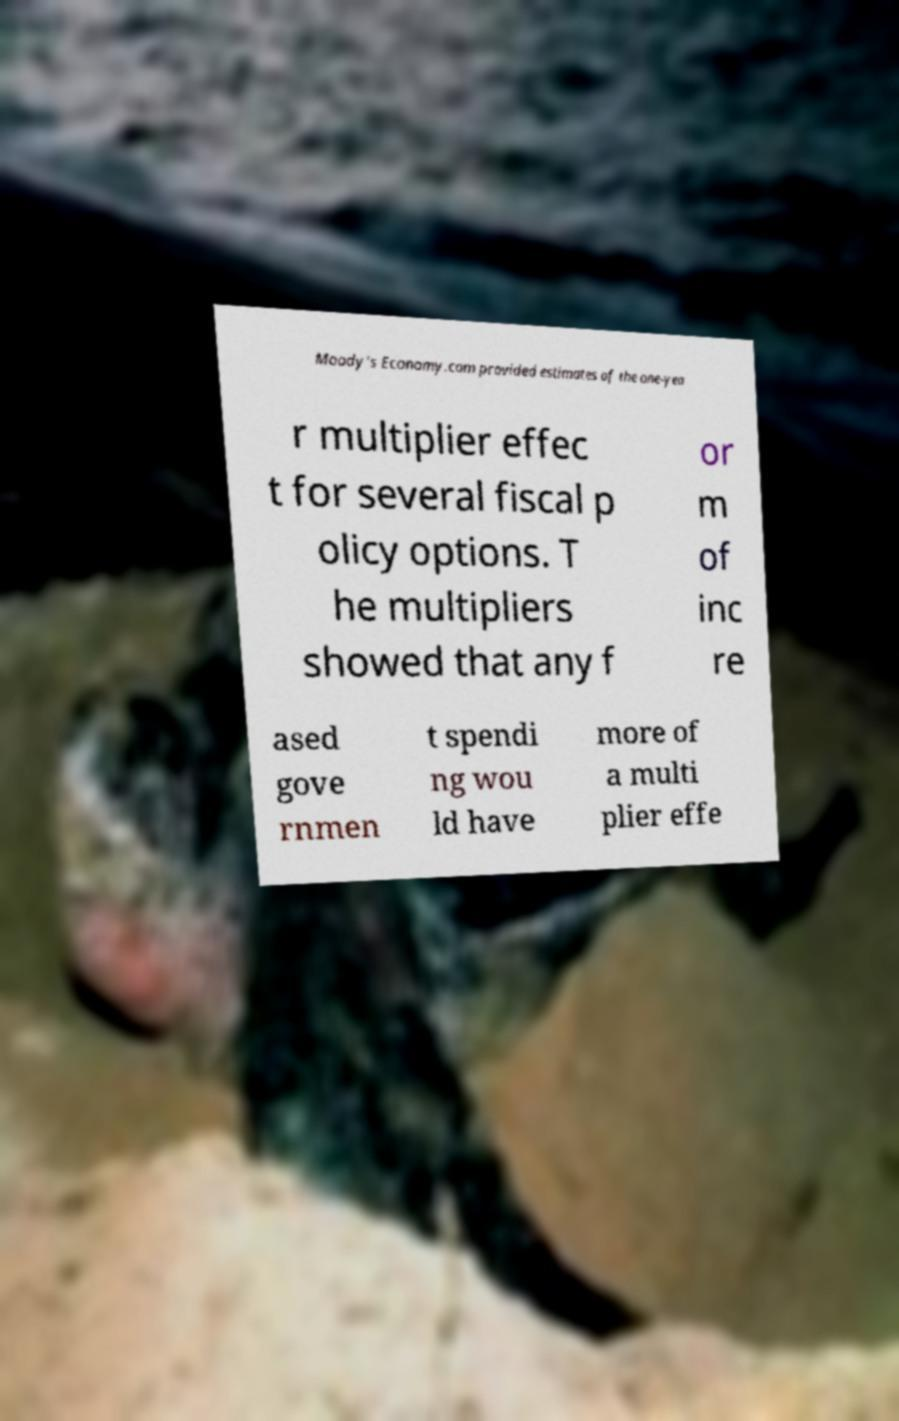Could you extract and type out the text from this image? Moody's Economy.com provided estimates of the one-yea r multiplier effec t for several fiscal p olicy options. T he multipliers showed that any f or m of inc re ased gove rnmen t spendi ng wou ld have more of a multi plier effe 